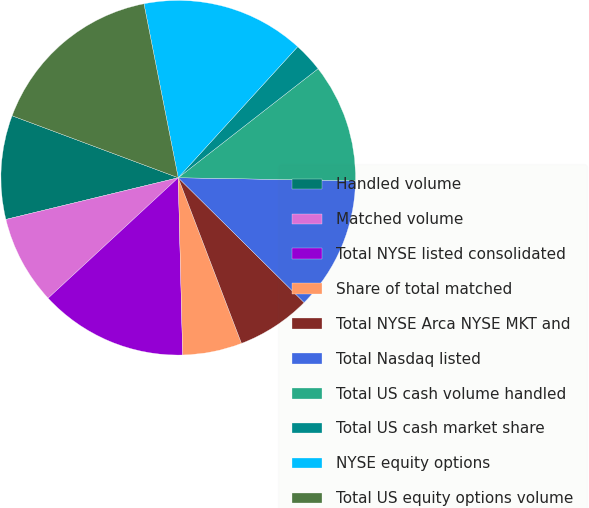Convert chart. <chart><loc_0><loc_0><loc_500><loc_500><pie_chart><fcel>Handled volume<fcel>Matched volume<fcel>Total NYSE listed consolidated<fcel>Share of total matched<fcel>Total NYSE Arca NYSE MKT and<fcel>Total Nasdaq listed<fcel>Total US cash volume handled<fcel>Total US cash market share<fcel>NYSE equity options<fcel>Total US equity options volume<nl><fcel>9.46%<fcel>8.11%<fcel>13.51%<fcel>5.41%<fcel>6.76%<fcel>12.16%<fcel>10.81%<fcel>2.7%<fcel>14.86%<fcel>16.22%<nl></chart> 